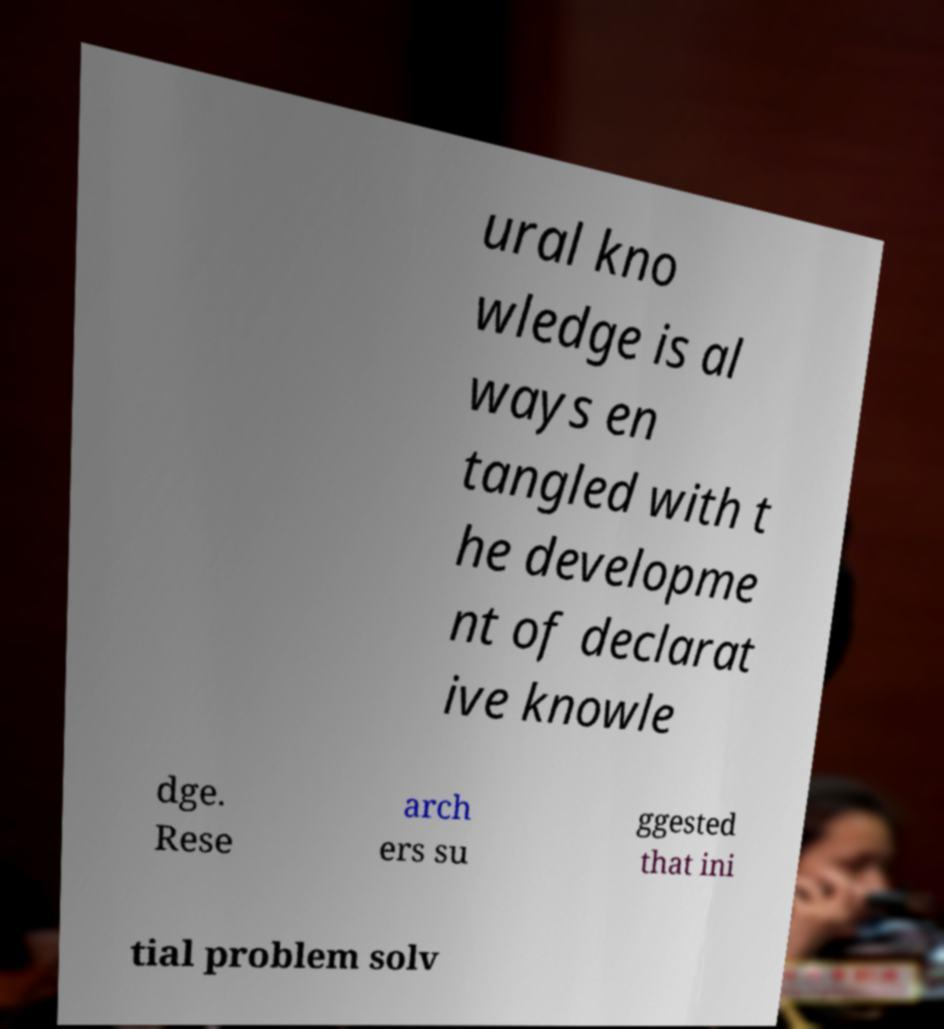What messages or text are displayed in this image? I need them in a readable, typed format. ural kno wledge is al ways en tangled with t he developme nt of declarat ive knowle dge. Rese arch ers su ggested that ini tial problem solv 